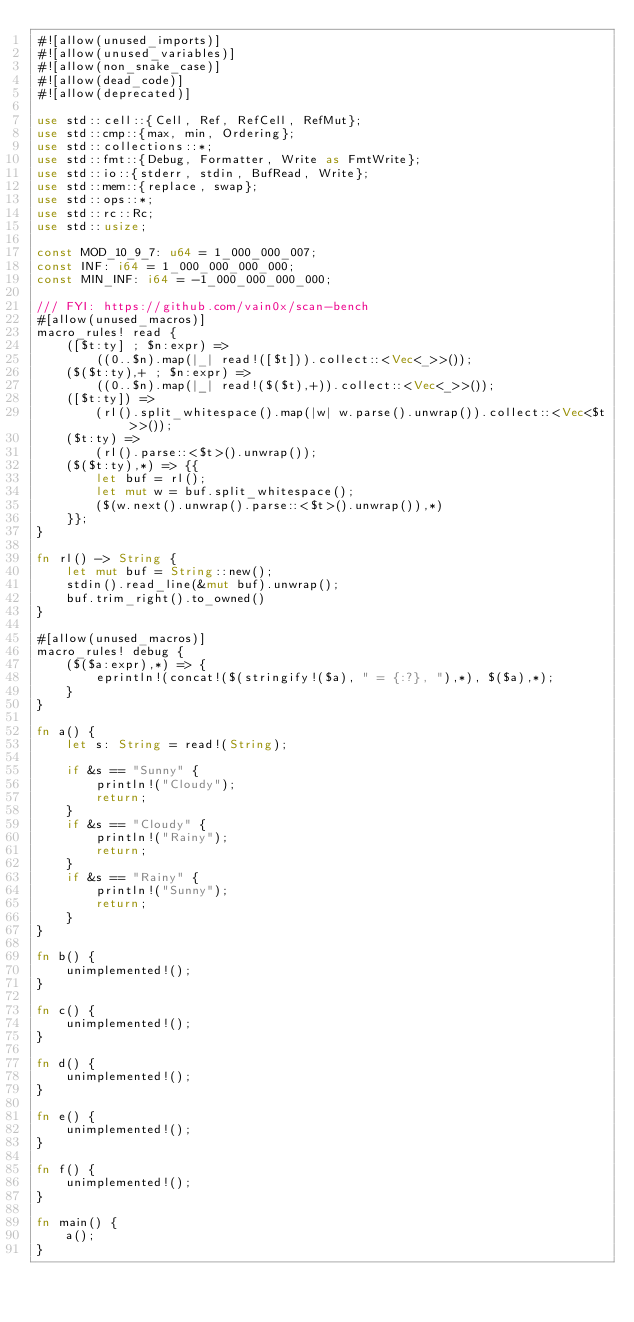<code> <loc_0><loc_0><loc_500><loc_500><_Rust_>#![allow(unused_imports)]
#![allow(unused_variables)]
#![allow(non_snake_case)]
#![allow(dead_code)]
#![allow(deprecated)]

use std::cell::{Cell, Ref, RefCell, RefMut};
use std::cmp::{max, min, Ordering};
use std::collections::*;
use std::fmt::{Debug, Formatter, Write as FmtWrite};
use std::io::{stderr, stdin, BufRead, Write};
use std::mem::{replace, swap};
use std::ops::*;
use std::rc::Rc;
use std::usize;

const MOD_10_9_7: u64 = 1_000_000_007;
const INF: i64 = 1_000_000_000_000;
const MIN_INF: i64 = -1_000_000_000_000;

/// FYI: https://github.com/vain0x/scan-bench
#[allow(unused_macros)]
macro_rules! read {
    ([$t:ty] ; $n:expr) =>
        ((0..$n).map(|_| read!([$t])).collect::<Vec<_>>());
    ($($t:ty),+ ; $n:expr) =>
        ((0..$n).map(|_| read!($($t),+)).collect::<Vec<_>>());
    ([$t:ty]) =>
        (rl().split_whitespace().map(|w| w.parse().unwrap()).collect::<Vec<$t>>());
    ($t:ty) =>
        (rl().parse::<$t>().unwrap());
    ($($t:ty),*) => {{
        let buf = rl();
        let mut w = buf.split_whitespace();
        ($(w.next().unwrap().parse::<$t>().unwrap()),*)
    }};
}

fn rl() -> String {
    let mut buf = String::new();
    stdin().read_line(&mut buf).unwrap();
    buf.trim_right().to_owned()
}

#[allow(unused_macros)]
macro_rules! debug {
    ($($a:expr),*) => {
        eprintln!(concat!($(stringify!($a), " = {:?}, "),*), $($a),*);
    }
}

fn a() {
    let s: String = read!(String);

    if &s == "Sunny" {
        println!("Cloudy");
        return;
    }
    if &s == "Cloudy" {
        println!("Rainy");
        return;
    }
    if &s == "Rainy" {
        println!("Sunny");
        return;
    }
}

fn b() {
    unimplemented!();
}

fn c() {
    unimplemented!();
}

fn d() {
    unimplemented!();
}

fn e() {
    unimplemented!();
}

fn f() {
    unimplemented!();
}

fn main() {
    a();
}
</code> 